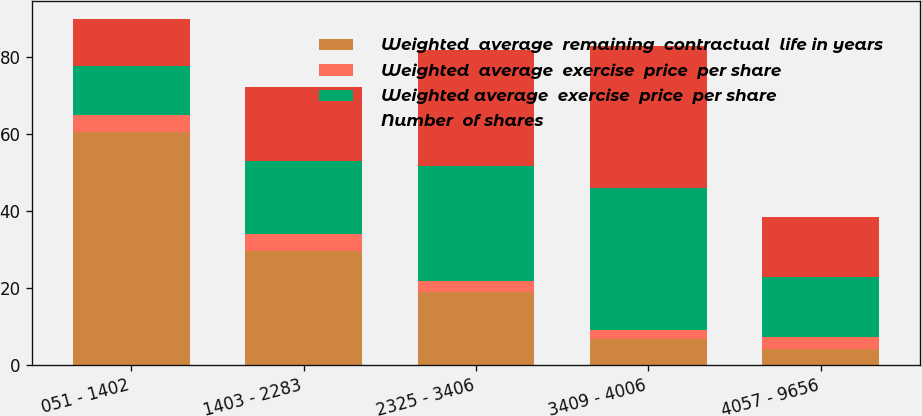Convert chart to OTSL. <chart><loc_0><loc_0><loc_500><loc_500><stacked_bar_chart><ecel><fcel>051 - 1402<fcel>1403 - 2283<fcel>2325 - 3406<fcel>3409 - 4006<fcel>4057 - 9656<nl><fcel>Weighted  average  remaining  contractual  life in years<fcel>60.5<fcel>29.6<fcel>18.8<fcel>6.6<fcel>4<nl><fcel>Weighted  average  exercise  price  per share<fcel>4.43<fcel>4.4<fcel>2.86<fcel>2.38<fcel>3.11<nl><fcel>Weighted average  exercise  price  per share<fcel>12.51<fcel>18.87<fcel>29.97<fcel>36.93<fcel>15.655<nl><fcel>Number  of shares<fcel>12.43<fcel>19.22<fcel>29.97<fcel>36.93<fcel>15.655<nl></chart> 